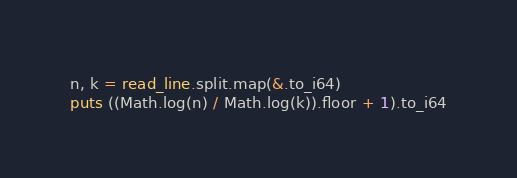<code> <loc_0><loc_0><loc_500><loc_500><_Crystal_>n, k = read_line.split.map(&.to_i64)
puts ((Math.log(n) / Math.log(k)).floor + 1).to_i64
</code> 